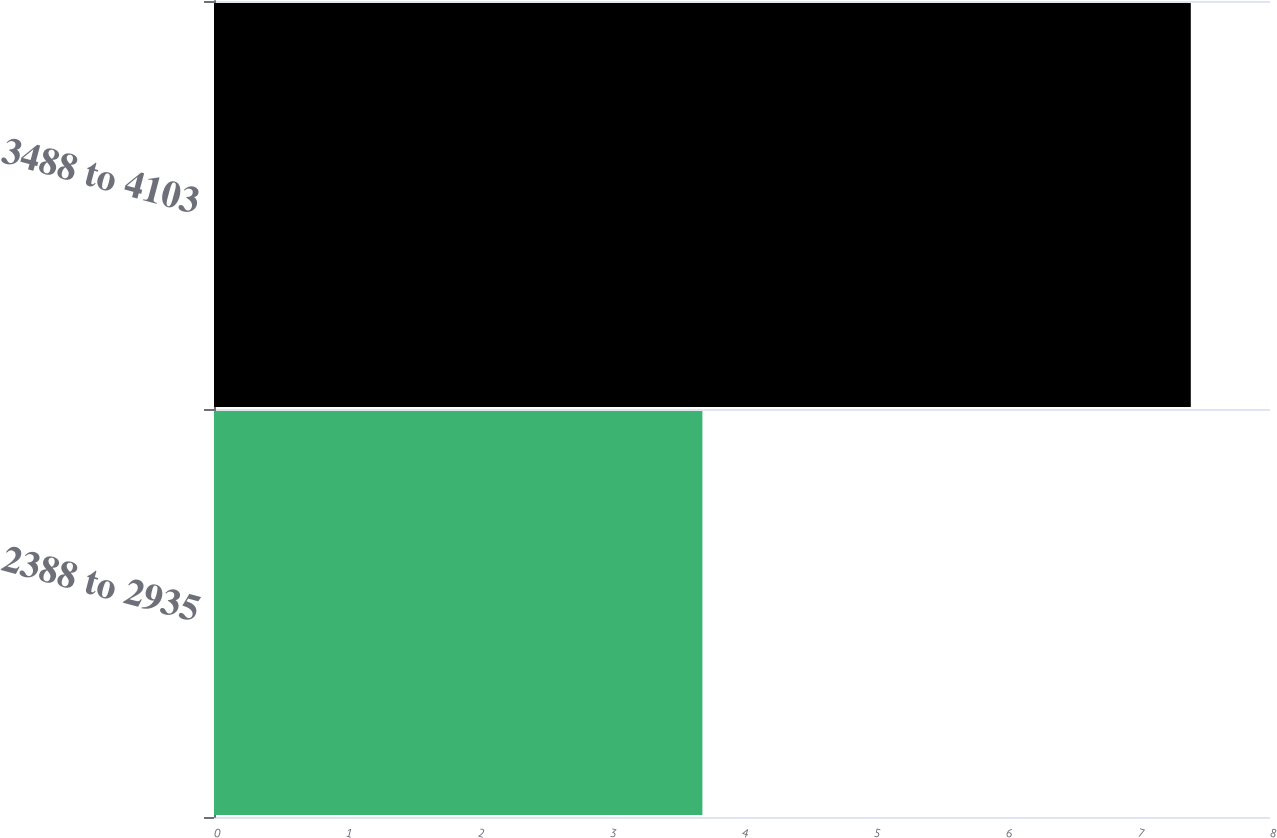Convert chart. <chart><loc_0><loc_0><loc_500><loc_500><bar_chart><fcel>2388 to 2935<fcel>3488 to 4103<nl><fcel>3.7<fcel>7.4<nl></chart> 